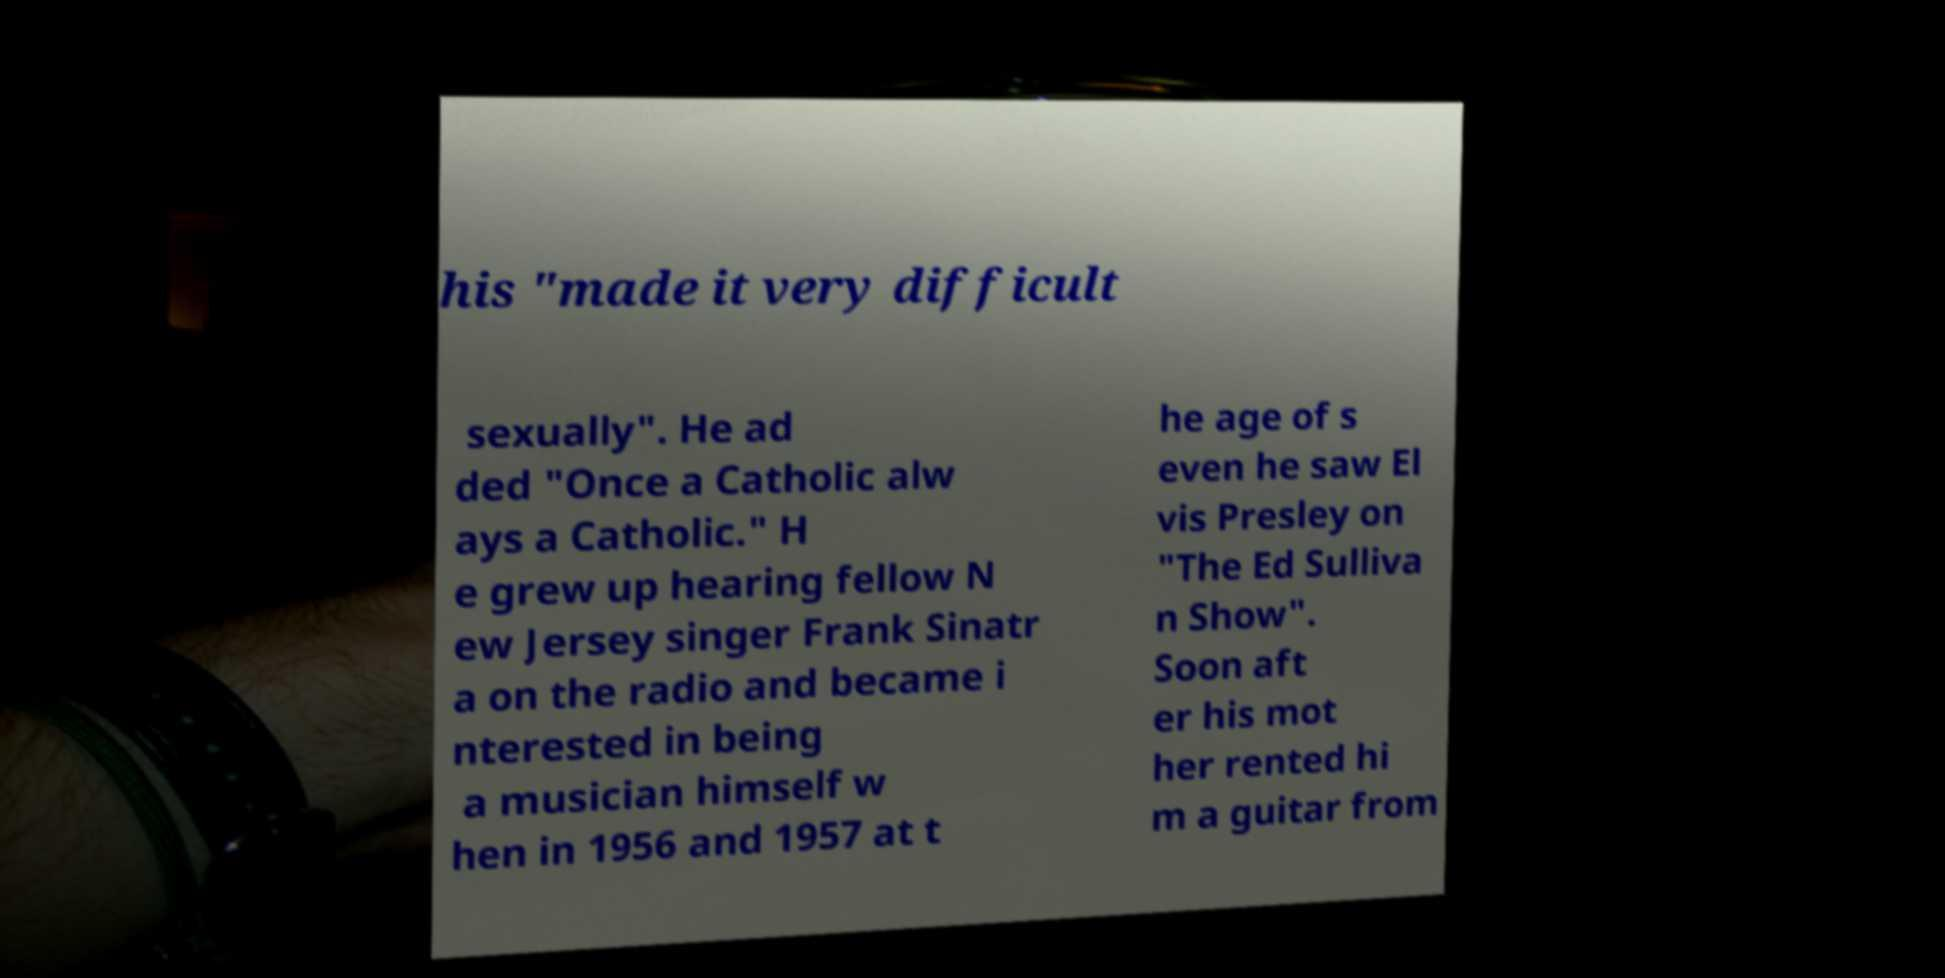There's text embedded in this image that I need extracted. Can you transcribe it verbatim? his "made it very difficult sexually". He ad ded "Once a Catholic alw ays a Catholic." H e grew up hearing fellow N ew Jersey singer Frank Sinatr a on the radio and became i nterested in being a musician himself w hen in 1956 and 1957 at t he age of s even he saw El vis Presley on "The Ed Sulliva n Show". Soon aft er his mot her rented hi m a guitar from 